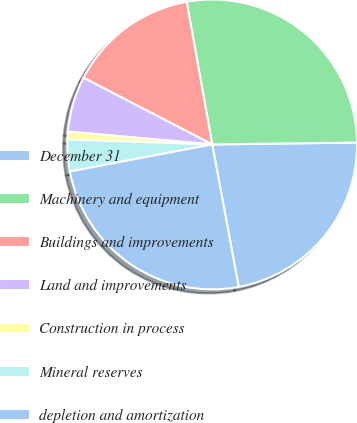<chart> <loc_0><loc_0><loc_500><loc_500><pie_chart><fcel>December 31<fcel>Machinery and equipment<fcel>Buildings and improvements<fcel>Land and improvements<fcel>Construction in process<fcel>Mineral reserves<fcel>depletion and amortization<nl><fcel>22.28%<fcel>27.61%<fcel>14.57%<fcel>6.2%<fcel>0.87%<fcel>3.53%<fcel>24.94%<nl></chart> 